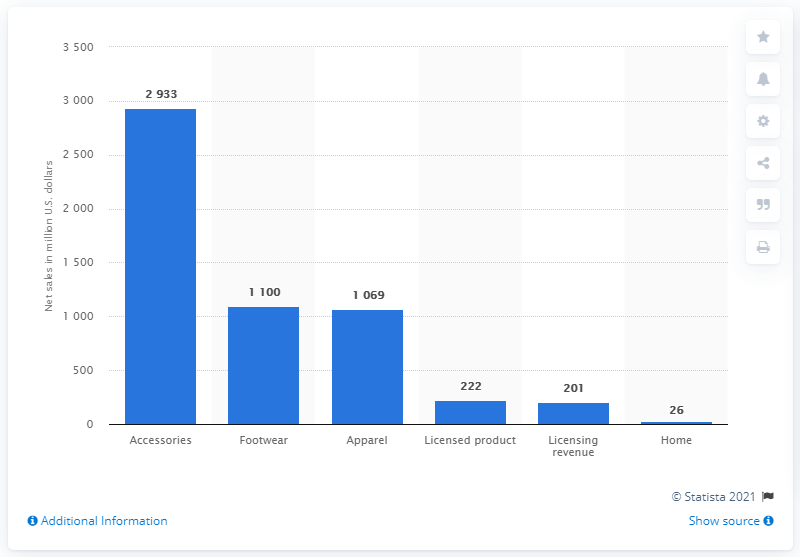Highlight a few significant elements in this photo. In 2020, the footwear segment of Capri Holdings generated net sales of approximately $1100 million. 